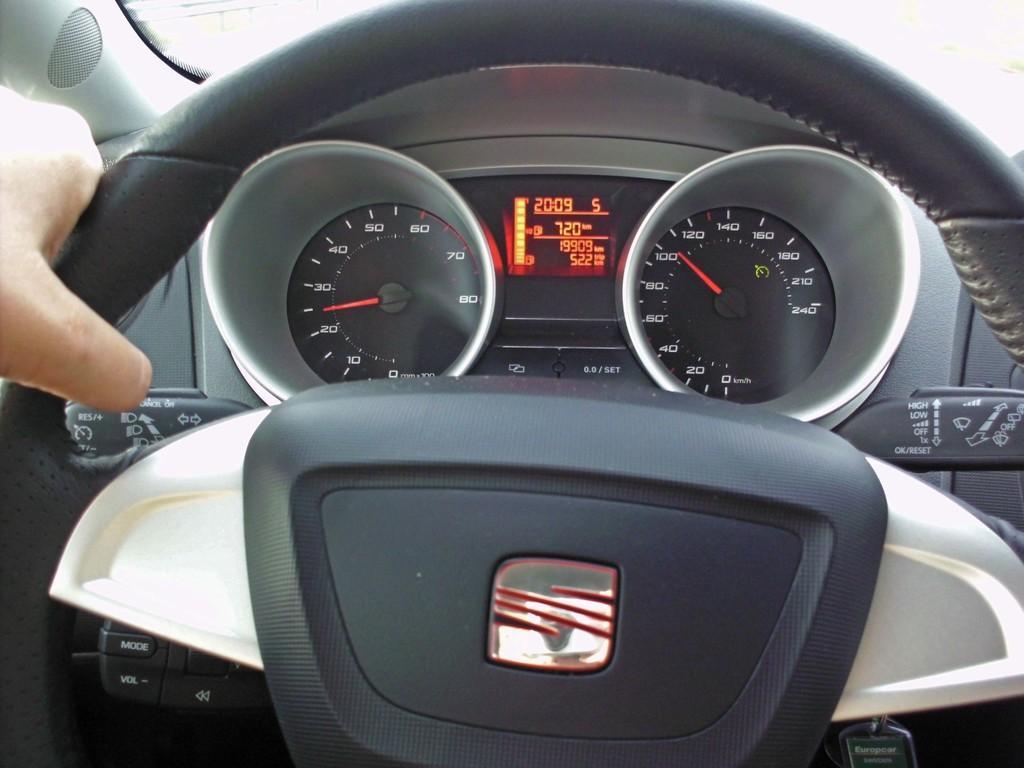Describe this image in one or two sentences. In this image I can see a person's hand on the steering of the vehicle and I can see the speedometer of the vehicle which is grey, black, orange and red in color. 